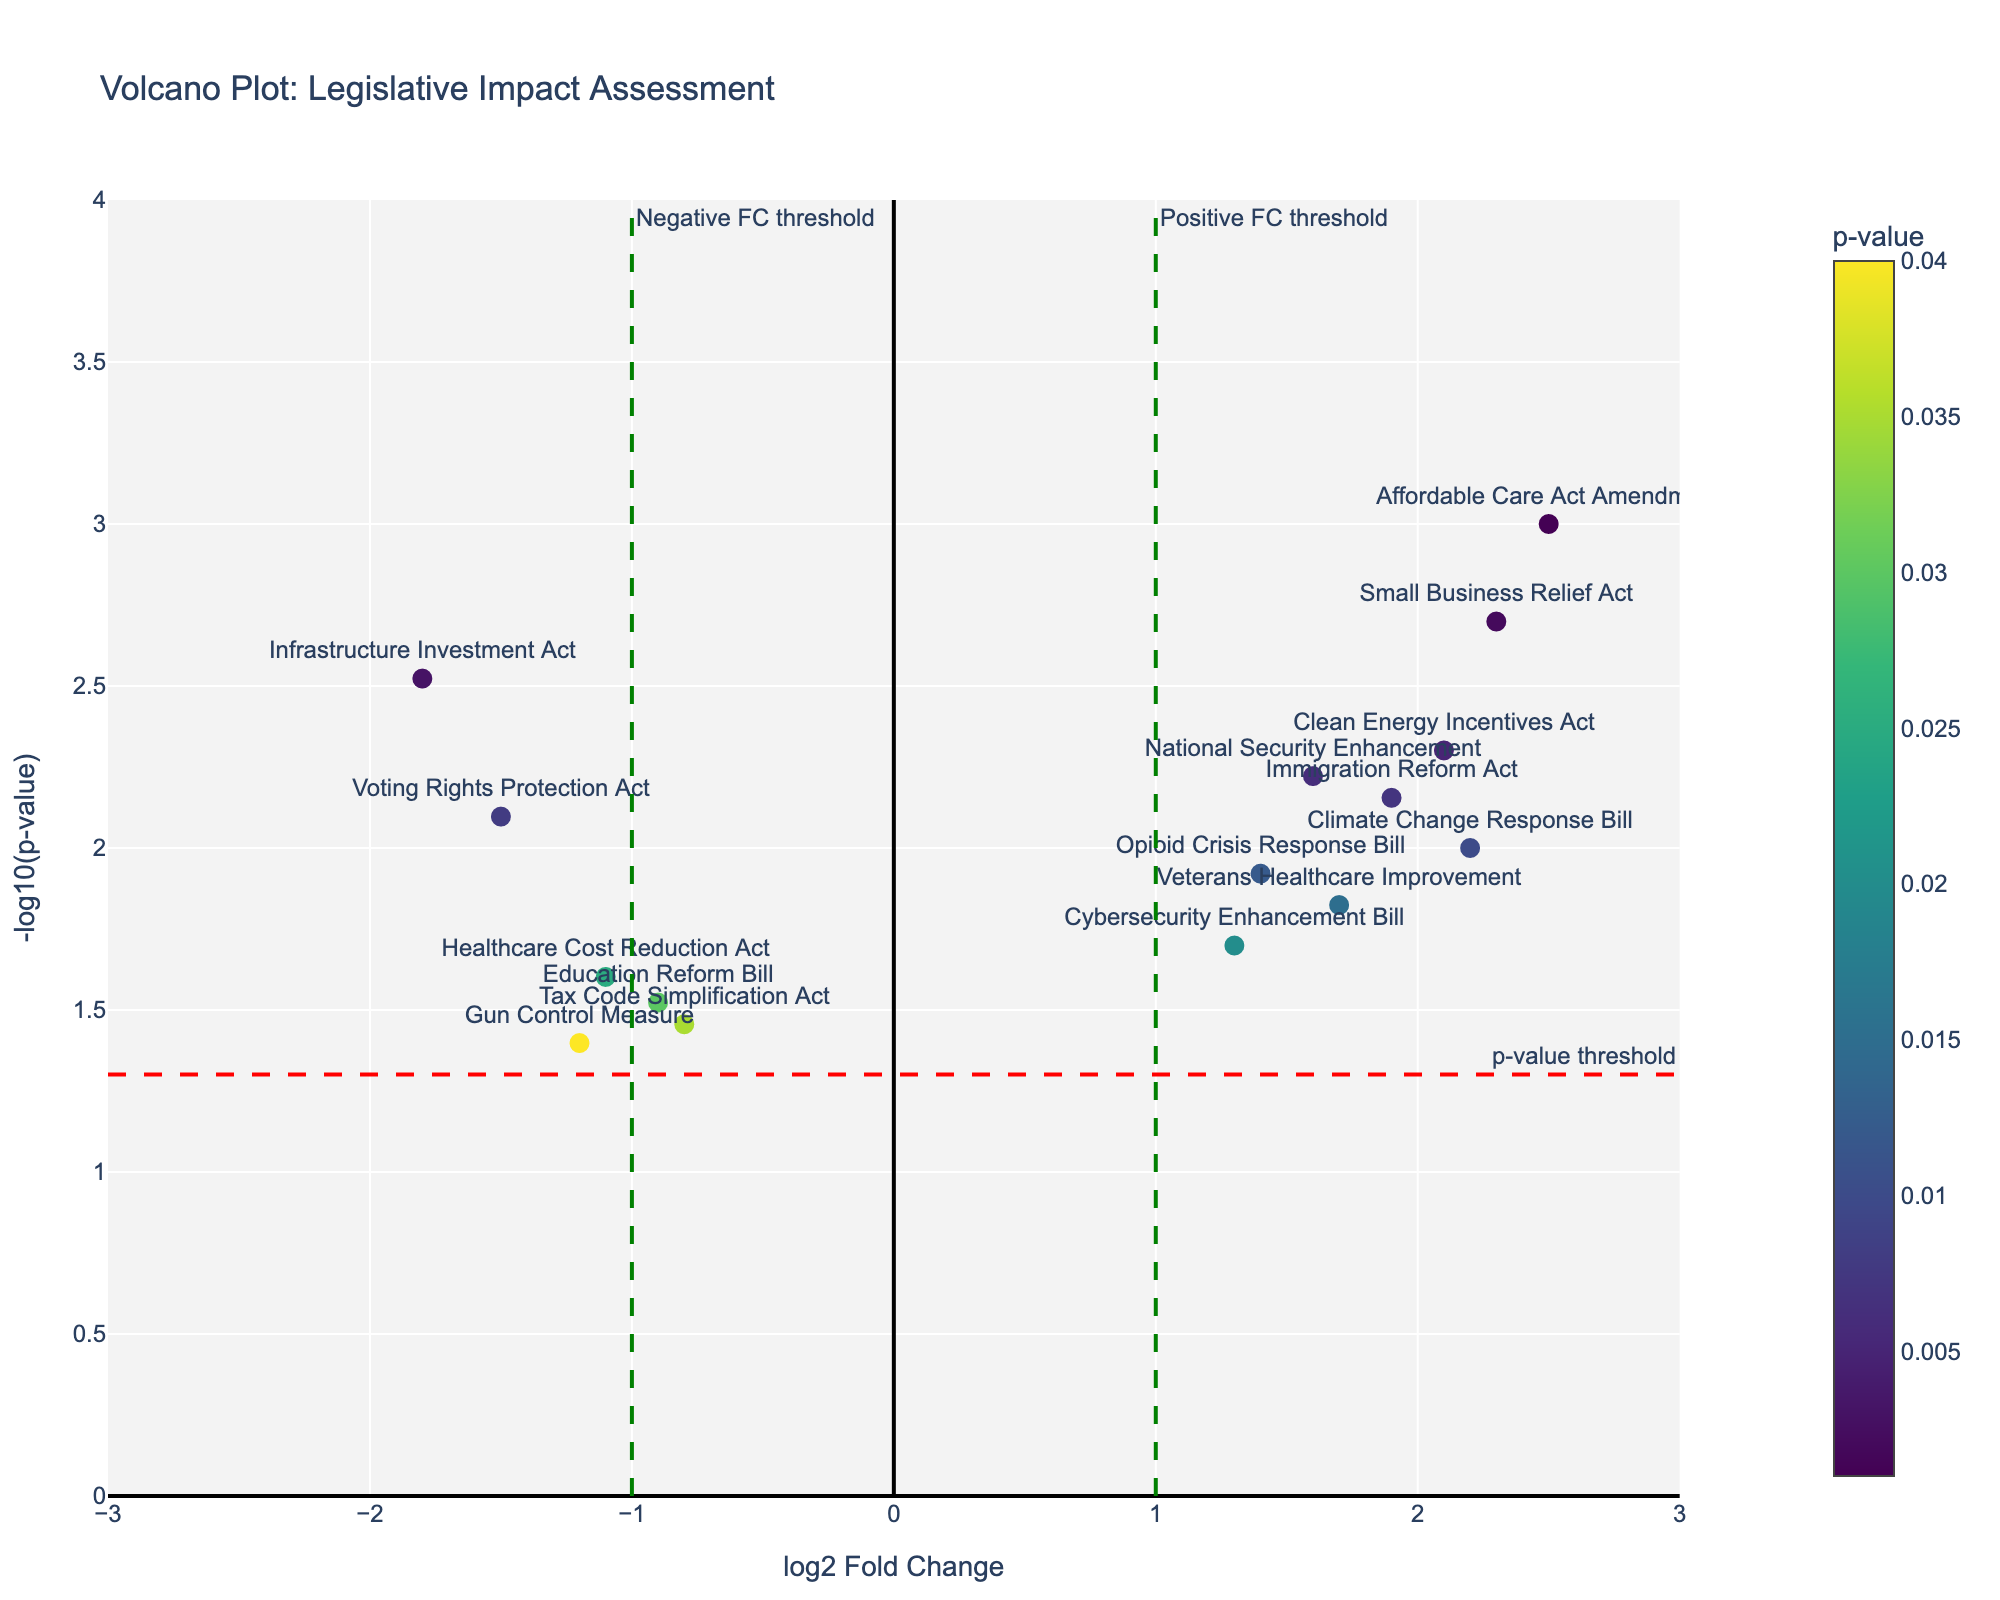How many bills are represented by each point in the plot? Each point in the plot represents an individual bill. Counting the points directly from the visual will give the number of bills. There are 15 points on the plot.
Answer: 15 What is the title of the figure? The title of the figure is displayed at the top of the plot. It reads "Volcano Plot: Legislative Impact Assessment".
Answer: Volcano Plot: Legislative Impact Assessment Which bill has the highest log2 fold change? On the horizontal axis (log2 Fold Change), the most rightward point represents the bill with the highest log2 fold change. That bill is the “Affordable Care Act Amendment” with a log2 fold change of 2.5.
Answer: Affordable Care Act Amendment Are there more bills with positive or negative log2 fold change? By observing the number of points on the left (negative) versus those on the right (positive) of the vertical axis (0), you can count and compare. There are 6 bills with a negative log2 fold change and 9 with a positive log2 fold change. Therefore, there are more bills with a positive log2 fold change.
Answer: Positive Which bill has the highest statistical significance? The highest statistical significance corresponds to the lowest p-value, which appears as the highest point on the vertical axis (-log10(p-value)). The “Affordable Care Act Amendment” is the highest point on the plot, denoting the lowest p-value of 0.001.
Answer: Affordable Care Act Amendment Which thresholds are marked with green dashed lines? The green dashed lines on the horizontal axis mark the positive and negative log2 fold change thresholds at ±1.0 as indicated by their annotations.
Answer: ±1.0 Are there any bills with a log2 fold change exactly at the positive threshold? By looking closely at the plot, you can check if any points exactly align with the green dashed vertical line at log2 fold change = 1.0. There are no points exactly at this threshold.
Answer: No Which bill has the lowest log2 fold change among those with a p-value below the threshold of 0.05 (marked by a red dashed line)? You need to find the points above the red dashed line (significant p-values) and identify the one farthest to the left. The “Infrastructure Investment Act” has a log2 fold change of -1.8, which is the lowest among that category.
Answer: Infrastructure Investment Act How many bills in total are both statistically significant and have a positive log2 fold change? Points that are both above the horizontal red dashed line (statistically significant) and right of the vertical green dashed line (positive log2 fold change) must be counted. There are 7 such points: Affordable Care Act Amendment, Clean Energy Incentives Act, Small Business Relief Act, Immigration Reform Act, Veterans Healthcare Improvement, Climate Change Response Bill, and National Security Enhancement.
Answer: 7 Which bill has a higher p-value, the “Cybersecurity Enhancement Bill” or the “Gun Control Measure”? By checking the vertical positions of the two points representing these bills on the plot, you can see which is lower. The “Gun Control Measure” is closer to the baseline, hence it has a higher p-value.
Answer: Gun Control Measure 